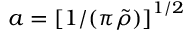<formula> <loc_0><loc_0><loc_500><loc_500>a = \left [ 1 / ( \pi \tilde { \rho } ) \right ] ^ { 1 / 2 }</formula> 